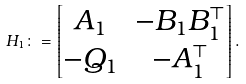Convert formula to latex. <formula><loc_0><loc_0><loc_500><loc_500>H _ { 1 } \colon = \begin{bmatrix} A _ { 1 } & - B _ { 1 } B _ { 1 } ^ { \top } \\ - Q _ { 1 } & - A _ { 1 } ^ { \top } \end{bmatrix} .</formula> 